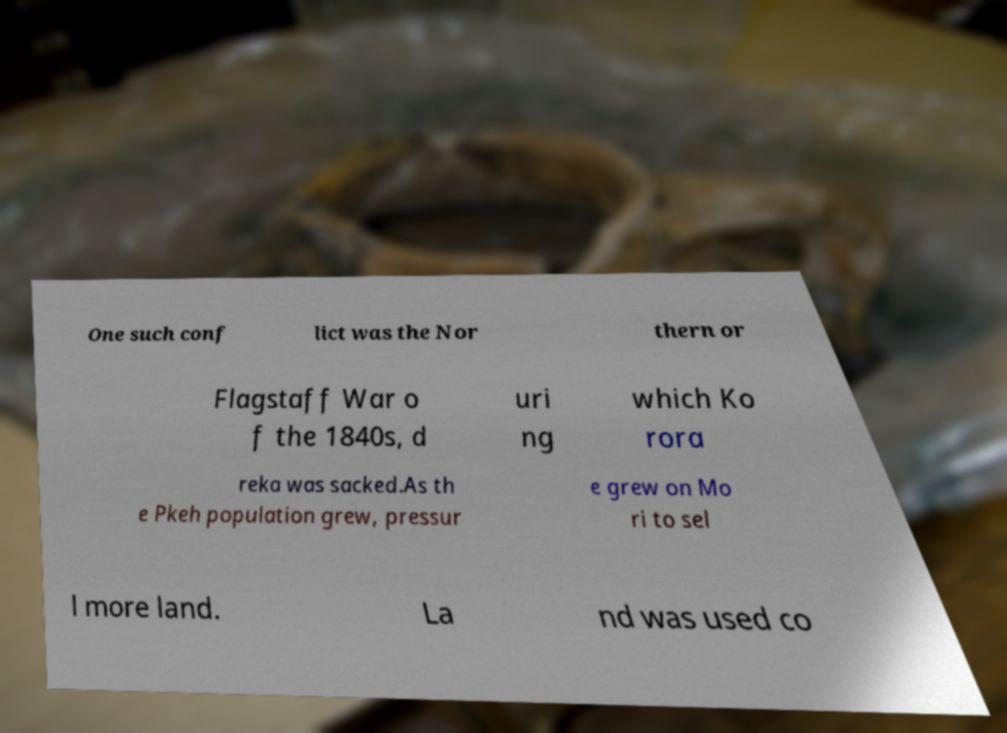Could you extract and type out the text from this image? One such conf lict was the Nor thern or Flagstaff War o f the 1840s, d uri ng which Ko rora reka was sacked.As th e Pkeh population grew, pressur e grew on Mo ri to sel l more land. La nd was used co 